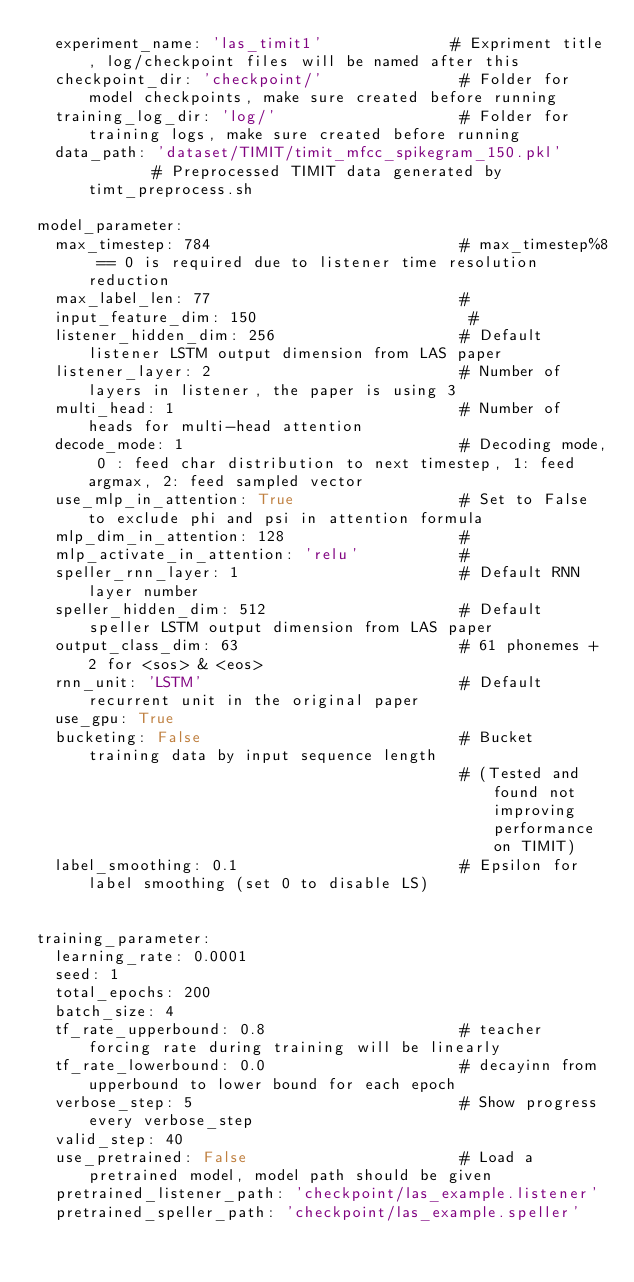Convert code to text. <code><loc_0><loc_0><loc_500><loc_500><_YAML_>  experiment_name: 'las_timit1'              # Expriment title, log/checkpoint files will be named after this
  checkpoint_dir: 'checkpoint/'               # Folder for model checkpoints, make sure created before running
  training_log_dir: 'log/'                    # Folder for training logs, make sure created before running
  data_path: 'dataset/TIMIT/timit_mfcc_spikegram_150.pkl'        # Preprocessed TIMIT data generated by timt_preprocess.sh

model_parameter:
  max_timestep: 784                           # max_timestep%8 == 0 is required due to listener time resolution reduction
  max_label_len: 77                           # 
  input_feature_dim: 150                       #
  listener_hidden_dim: 256                    # Default listener LSTM output dimension from LAS paper
  listener_layer: 2                           # Number of layers in listener, the paper is using 3
  multi_head: 1                               # Number of heads for multi-head attention
  decode_mode: 1                              # Decoding mode, 0 : feed char distribution to next timestep, 1: feed argmax, 2: feed sampled vector
  use_mlp_in_attention: True                  # Set to False to exclude phi and psi in attention formula
  mlp_dim_in_attention: 128                   #
  mlp_activate_in_attention: 'relu'           #
  speller_rnn_layer: 1                        # Default RNN layer number 
  speller_hidden_dim: 512                     # Default speller LSTM output dimension from LAS paper
  output_class_dim: 63                        # 61 phonemes + 2 for <sos> & <eos>
  rnn_unit: 'LSTM'                            # Default recurrent unit in the original paper
  use_gpu: True
  bucketing: False                            # Bucket training data by input sequence length
                                              # (Tested and found not improving performance on TIMIT)
  label_smoothing: 0.1                        # Epsilon for label smoothing (set 0 to disable LS)


training_parameter:
  learning_rate: 0.0001
  seed: 1
  total_epochs: 200
  batch_size: 4
  tf_rate_upperbound: 0.8                     # teacher forcing rate during training will be linearly
  tf_rate_lowerbound: 0.0                     # decayinn from upperbound to lower bound for each epoch
  verbose_step: 5                             # Show progress every verbose_step
  valid_step: 40
  use_pretrained: False                       # Load a pretrained model, model path should be given
  pretrained_listener_path: 'checkpoint/las_example.listener' 
  pretrained_speller_path: 'checkpoint/las_example.speller' 
</code> 